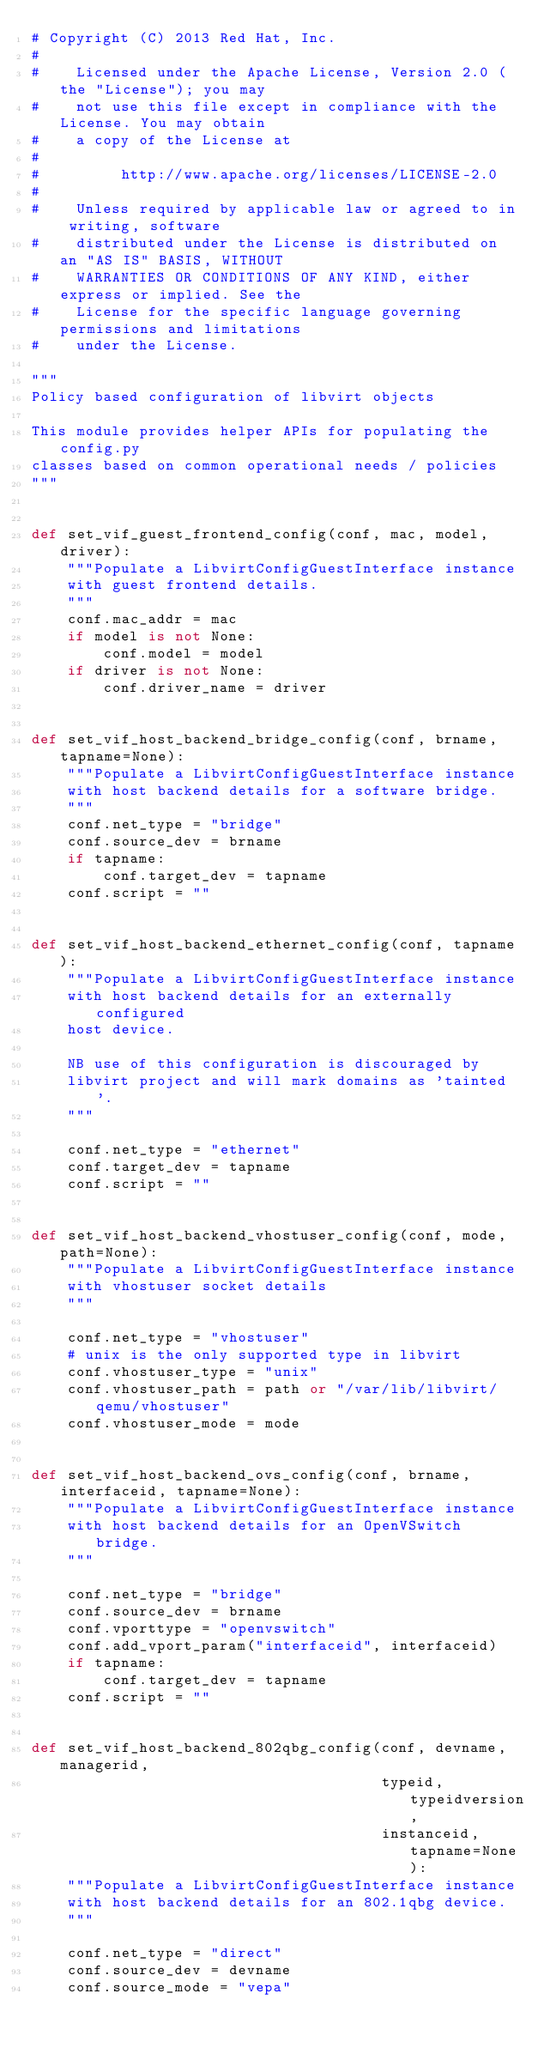Convert code to text. <code><loc_0><loc_0><loc_500><loc_500><_Python_># Copyright (C) 2013 Red Hat, Inc.
#
#    Licensed under the Apache License, Version 2.0 (the "License"); you may
#    not use this file except in compliance with the License. You may obtain
#    a copy of the License at
#
#         http://www.apache.org/licenses/LICENSE-2.0
#
#    Unless required by applicable law or agreed to in writing, software
#    distributed under the License is distributed on an "AS IS" BASIS, WITHOUT
#    WARRANTIES OR CONDITIONS OF ANY KIND, either express or implied. See the
#    License for the specific language governing permissions and limitations
#    under the License.

"""
Policy based configuration of libvirt objects

This module provides helper APIs for populating the config.py
classes based on common operational needs / policies
"""


def set_vif_guest_frontend_config(conf, mac, model, driver):
    """Populate a LibvirtConfigGuestInterface instance
    with guest frontend details.
    """
    conf.mac_addr = mac
    if model is not None:
        conf.model = model
    if driver is not None:
        conf.driver_name = driver


def set_vif_host_backend_bridge_config(conf, brname, tapname=None):
    """Populate a LibvirtConfigGuestInterface instance
    with host backend details for a software bridge.
    """
    conf.net_type = "bridge"
    conf.source_dev = brname
    if tapname:
        conf.target_dev = tapname
    conf.script = ""


def set_vif_host_backend_ethernet_config(conf, tapname):
    """Populate a LibvirtConfigGuestInterface instance
    with host backend details for an externally configured
    host device.

    NB use of this configuration is discouraged by
    libvirt project and will mark domains as 'tainted'.
    """

    conf.net_type = "ethernet"
    conf.target_dev = tapname
    conf.script = ""


def set_vif_host_backend_vhostuser_config(conf, mode, path=None):
    """Populate a LibvirtConfigGuestInterface instance
    with vhostuser socket details
    """

    conf.net_type = "vhostuser"
    # unix is the only supported type in libvirt
    conf.vhostuser_type = "unix"
    conf.vhostuser_path = path or "/var/lib/libvirt/qemu/vhostuser"
    conf.vhostuser_mode = mode


def set_vif_host_backend_ovs_config(conf, brname, interfaceid, tapname=None):
    """Populate a LibvirtConfigGuestInterface instance
    with host backend details for an OpenVSwitch bridge.
    """

    conf.net_type = "bridge"
    conf.source_dev = brname
    conf.vporttype = "openvswitch"
    conf.add_vport_param("interfaceid", interfaceid)
    if tapname:
        conf.target_dev = tapname
    conf.script = ""


def set_vif_host_backend_802qbg_config(conf, devname, managerid,
                                       typeid, typeidversion,
                                       instanceid, tapname=None):
    """Populate a LibvirtConfigGuestInterface instance
    with host backend details for an 802.1qbg device.
    """

    conf.net_type = "direct"
    conf.source_dev = devname
    conf.source_mode = "vepa"</code> 